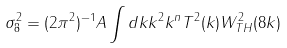<formula> <loc_0><loc_0><loc_500><loc_500>\sigma ^ { 2 } _ { 8 } = ( 2 \pi ^ { 2 } ) ^ { - 1 } A \int d k k ^ { 2 } k ^ { n } T ^ { 2 } ( k ) W _ { T H } ^ { 2 } ( 8 k )</formula> 